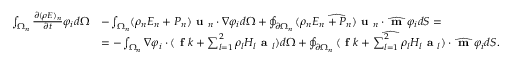Convert formula to latex. <formula><loc_0><loc_0><loc_500><loc_500>\begin{array} { r l } { \int _ { \Omega _ { n } } \frac { \partial ( \rho E ) _ { n } } { \partial t } \varphi _ { i } d \Omega } & { - \int _ { \Omega _ { n } } ( \rho _ { n } E _ { n } + P _ { n } ) u _ { n } \cdot \nabla \varphi _ { i } d \Omega + \oint _ { \partial \Omega _ { n } } \widehat { ( \rho _ { n } E _ { n } + P _ { n } ) u _ { n } } \cdot \widehat { m } \varphi _ { i } d S = } \\ & { = - \int _ { \Omega _ { n } } \nabla \varphi _ { i } \cdot ( f k + \sum _ { l = 1 } ^ { 2 } \rho _ { l } H _ { l } a _ { l } ) d \Omega + \oint _ { \partial \Omega _ { n } } \widehat { ( f k + \sum _ { l = 1 } ^ { 2 } \rho _ { l } H _ { l } a _ { l } ) } \cdot \widehat { m } \varphi _ { i } d S . } \end{array}</formula> 